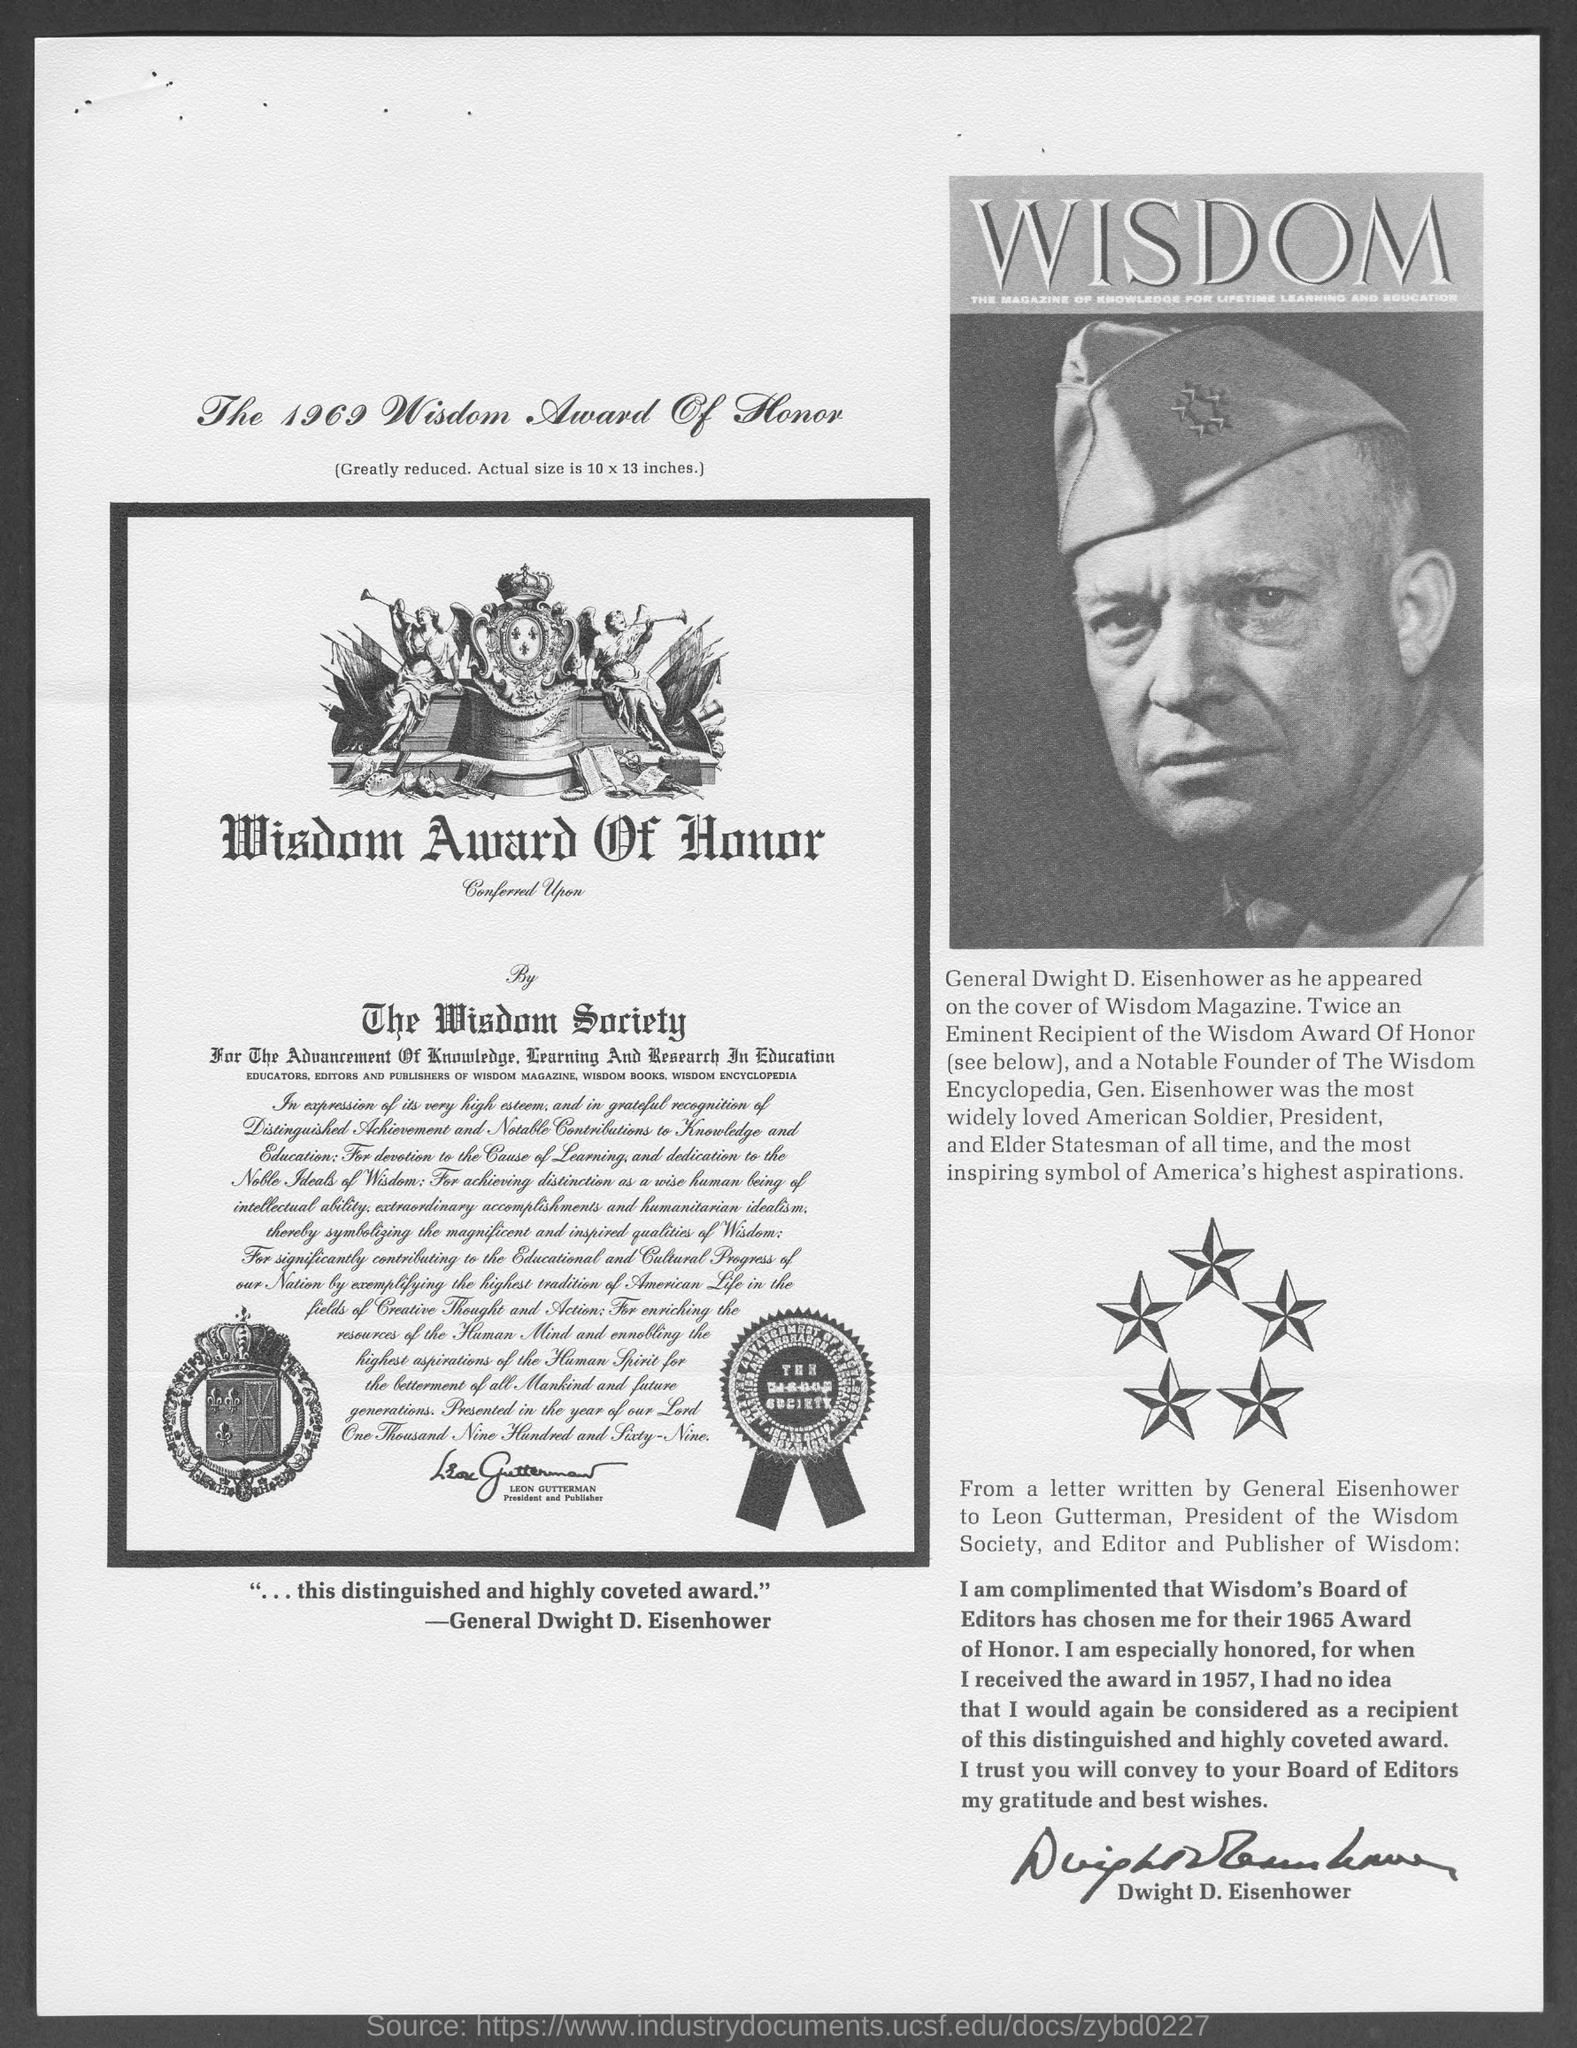Highlight a few significant elements in this photo. The year of Wisdom Award of Honor was 1969. Gen. Dwight D. Eisenhower was widely regarded as the most beloved American soldier. 